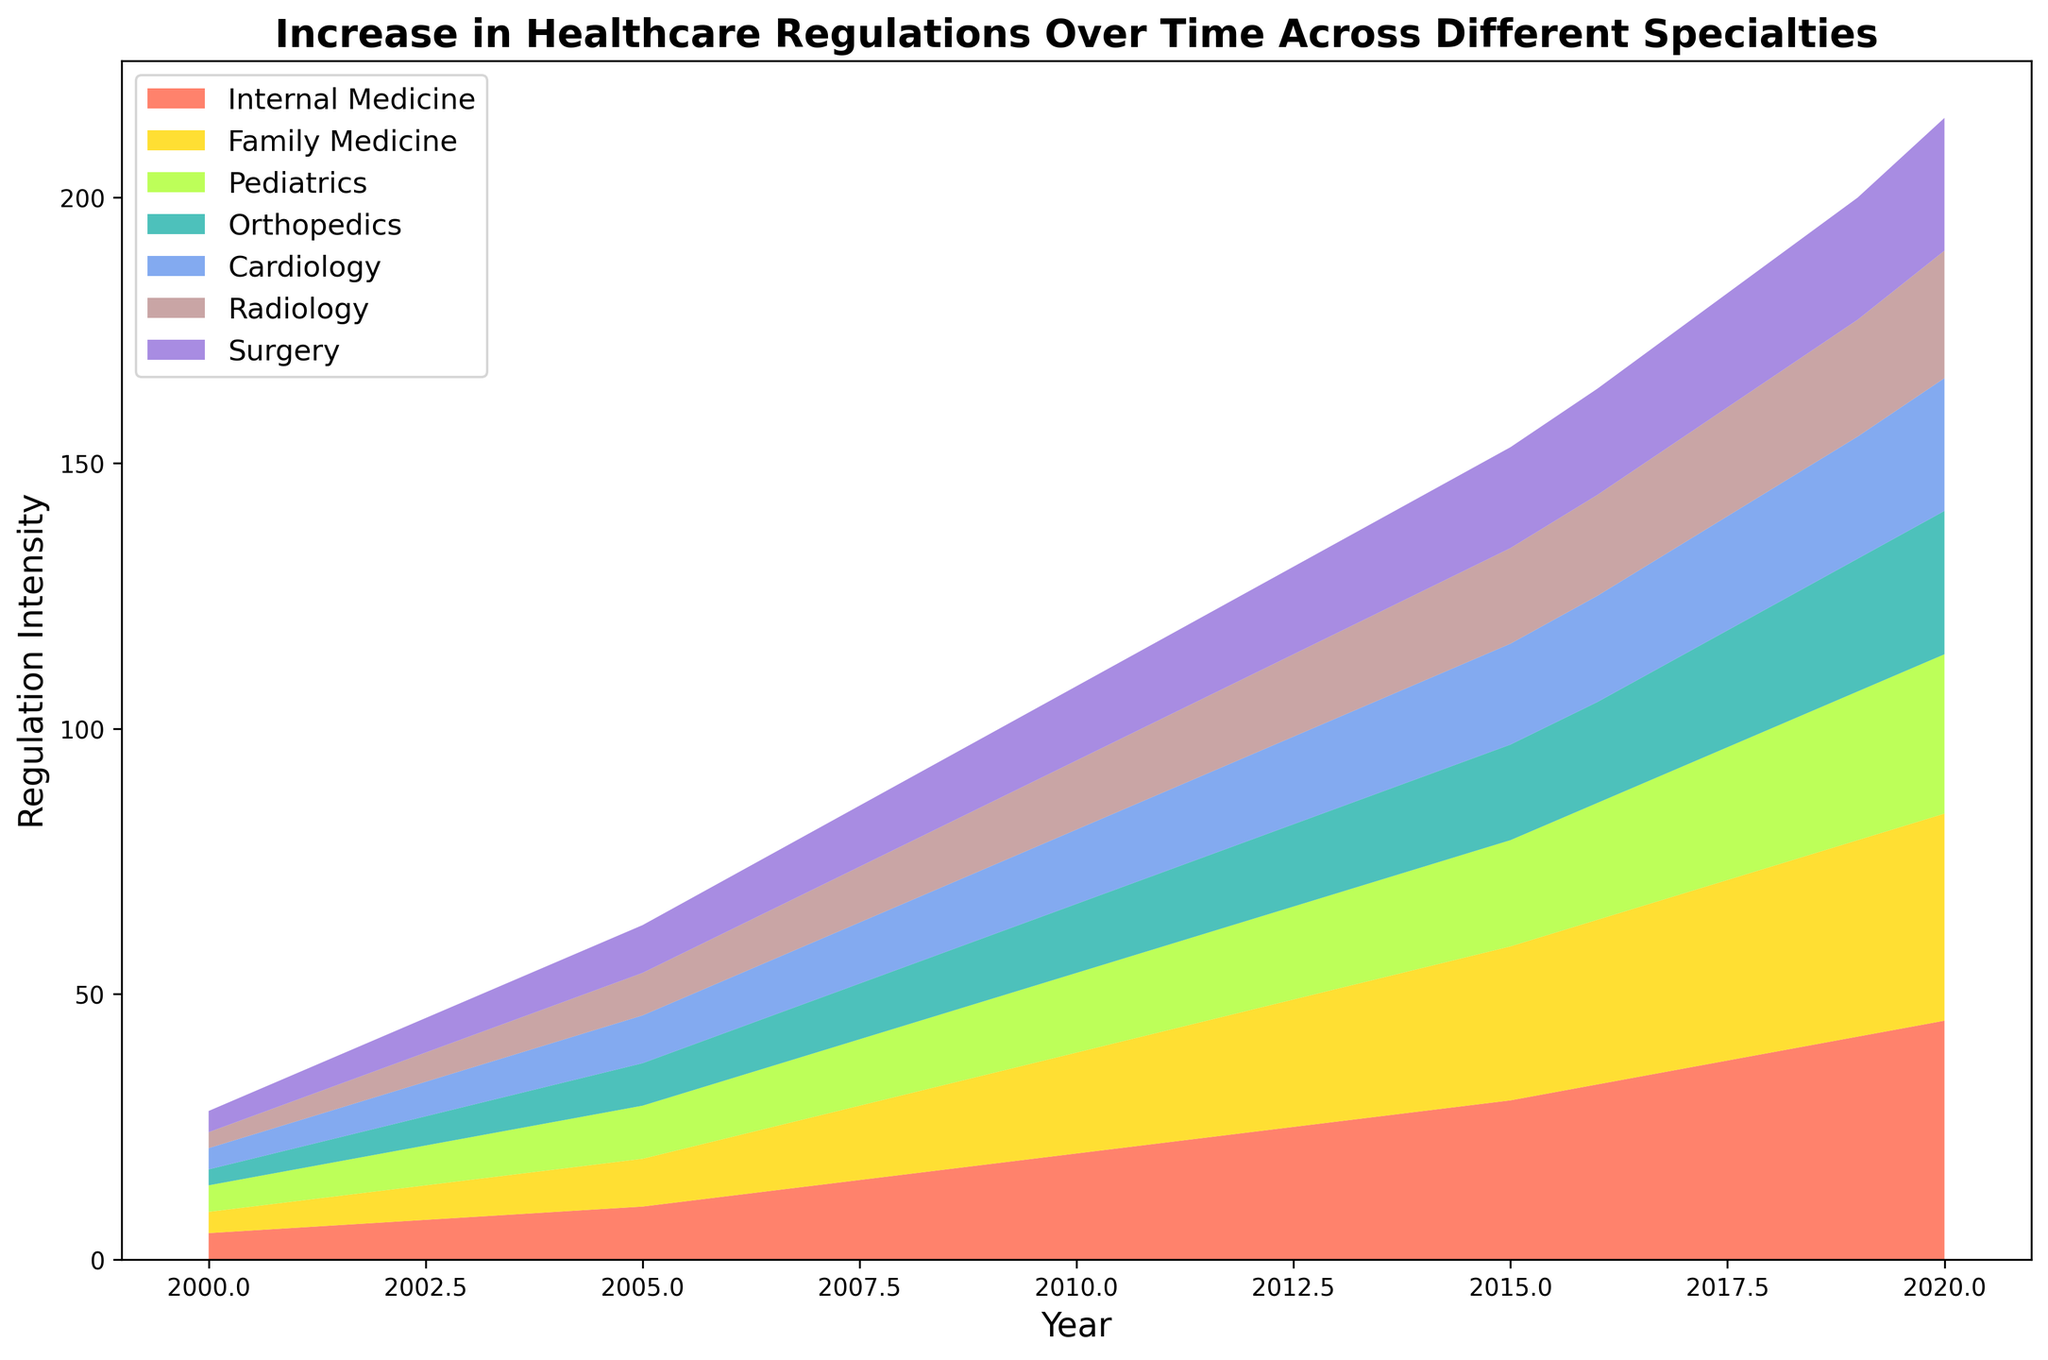What is the average increase in regulations for Internal Medicine between 2000 and 2005? To calculate the average increase, find the difference between the regulation values of 2000 (5) and 2005 (10) which gives 5. Then, divide this difference by the number of years (2005-2000 = 5 years). (10-5)/5 = 1
Answer: 1 Which specialty shows the least increase in regulations from 2000 to 2020? By visually examining the height of the areas at 2020, the Surgery specialty has the smallest final value among all. The increase in Surgery from 4 in 2000 to 25 in 2020 appears to be less compared to the others.
Answer: Surgery How does the regulation increase in Family Medicine in 2010 compare to that in Orthopedics in the same year? In 2010, Family Medicine has a regulation value of 19, while Orthopedics has a value of 13. Clearly, Family Medicine has a greater increase in regulations compared to Orthopedics.
Answer: Family Medicine is higher What is the total regulation intensity for all specialties combined in the year 2015? Sum up the regulation values of all specialties in 2015: 30 (Internal Medicine) + 29 (Family Medicine) + 20 (Pediatrics) + 18 (Orthopedics) + 19 (Cardiology) + 18 (Radiology) + 19 (Surgery) which equals 153.
Answer: 153 Across which consecutive years does Internal Medicine see the highest single-year increase in regulations? By checking the year-over-year increments for Internal Medicine, the increase from 2015 (30) to 2016 (33) is the highest single-year increase, which amounts to 3.
Answer: Between 2015 and 2016 Which color represents the Pediatrics specialty in the plot? Identify the color associated with the Pediatrics area in the plot. According to the provided color order, the fourth color listed for Pediatrics is yellow (close to chartreuse/green).
Answer: Yellow What was the regulation intensity for Cardiology in 2008, and how many points of increase did it experience compared to 2000? In 2008, Cardiology has a regulation intensity of 12. In 2000, it was 4. The increase is calculated as 12 - 4 = 8.
Answer: 8 points increase By what factor did the regulations in Radiology increase from 2000 to 2020? The regulation intensity for Radiology in 2020 is 24, and in 2000 it was 3. The factor of increase is 24/3 = 8.
Answer: By a factor of 8 Which specialty exhibits the fastest growth rate in regulations over the observed period? Observing the steepness and relative increments of the areas, Internal Medicine shows the fastest growth rate, going from 5 in 2000 to 45 in 2020. This increase of 40 units is the largest observed.
Answer: Internal Medicine 